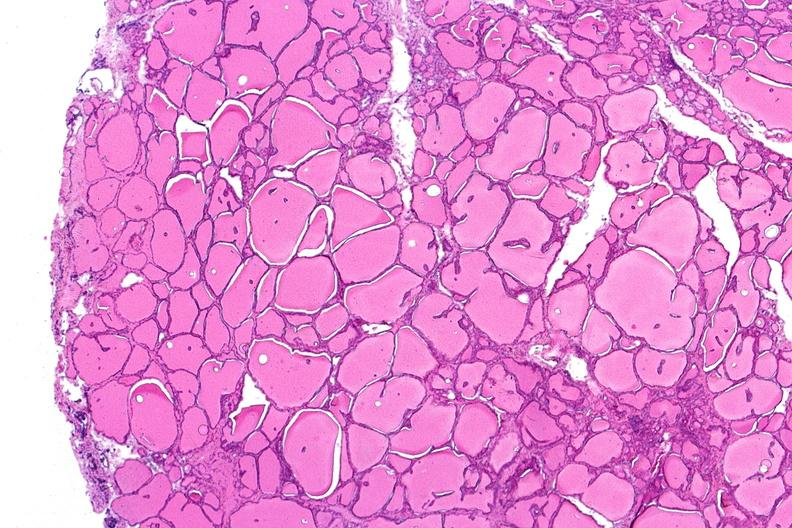does amyloidosis show thyroid, normal?
Answer the question using a single word or phrase. No 